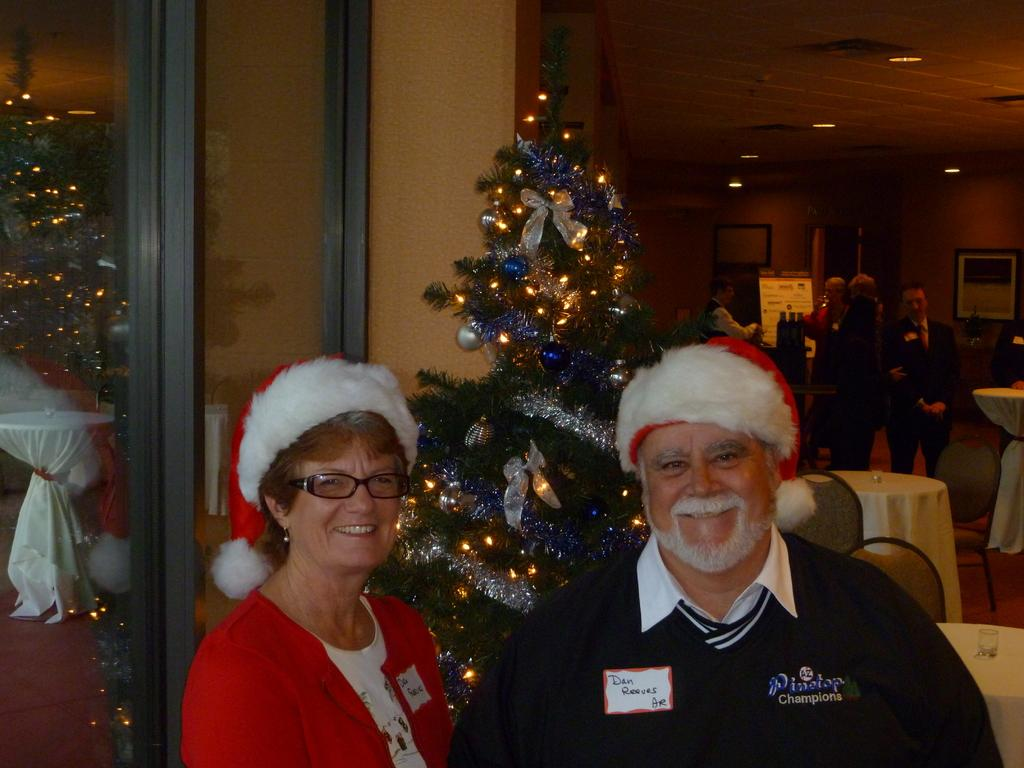<image>
Relay a brief, clear account of the picture shown. A woman is standing next to a man wearing a santa hat and a sweater that says Pinetop Champions. 